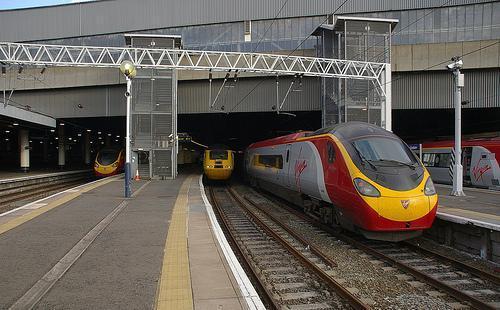How many women are standing on the platform between the trains?
Give a very brief answer. 0. 